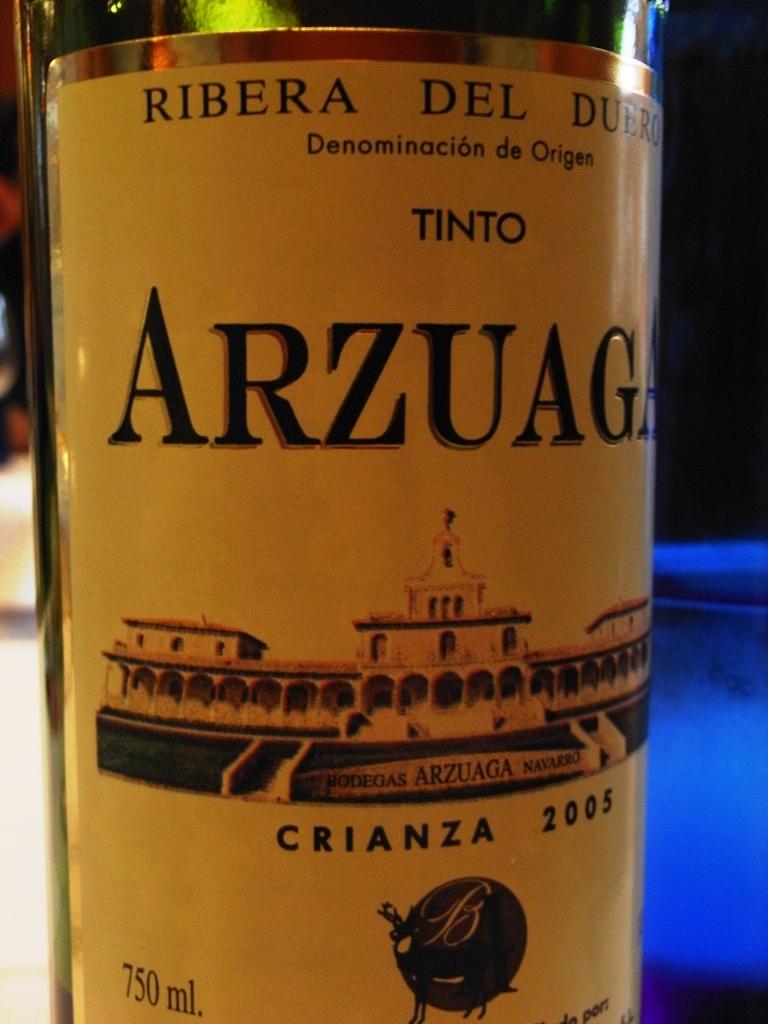What brand is this?
Keep it short and to the point. Arzuaga. 